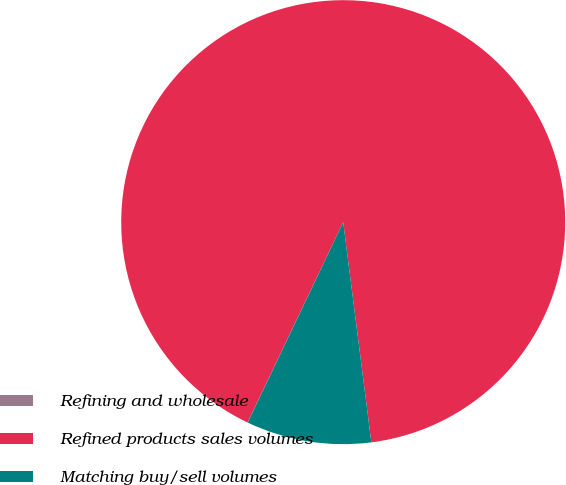Convert chart. <chart><loc_0><loc_0><loc_500><loc_500><pie_chart><fcel>Refining and wholesale<fcel>Refined products sales volumes<fcel>Matching buy/sell volumes<nl><fcel>0.01%<fcel>90.89%<fcel>9.1%<nl></chart> 